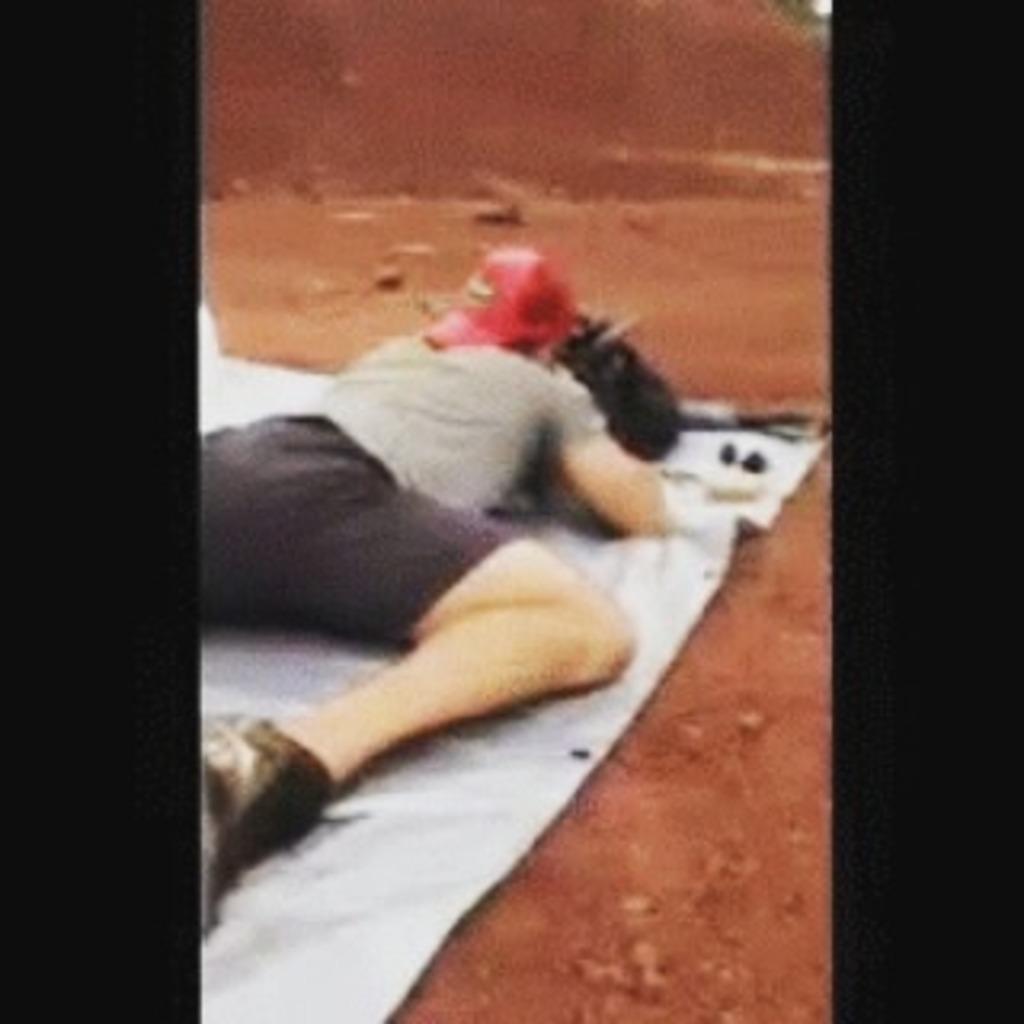In one or two sentences, can you explain what this image depicts? In the picture I can see a man is lying on a white color cloth. The man is wearing a red color object on head. I can also see some other objects on the ground. 